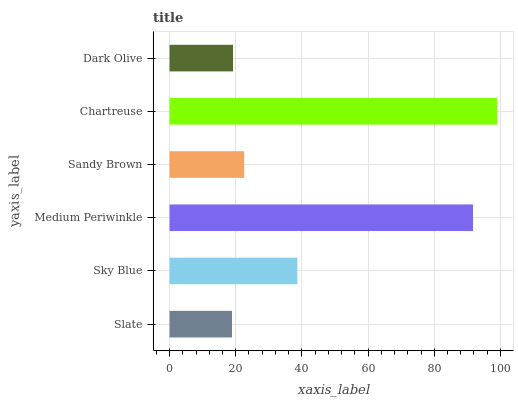Is Slate the minimum?
Answer yes or no. Yes. Is Chartreuse the maximum?
Answer yes or no. Yes. Is Sky Blue the minimum?
Answer yes or no. No. Is Sky Blue the maximum?
Answer yes or no. No. Is Sky Blue greater than Slate?
Answer yes or no. Yes. Is Slate less than Sky Blue?
Answer yes or no. Yes. Is Slate greater than Sky Blue?
Answer yes or no. No. Is Sky Blue less than Slate?
Answer yes or no. No. Is Sky Blue the high median?
Answer yes or no. Yes. Is Sandy Brown the low median?
Answer yes or no. Yes. Is Sandy Brown the high median?
Answer yes or no. No. Is Sky Blue the low median?
Answer yes or no. No. 